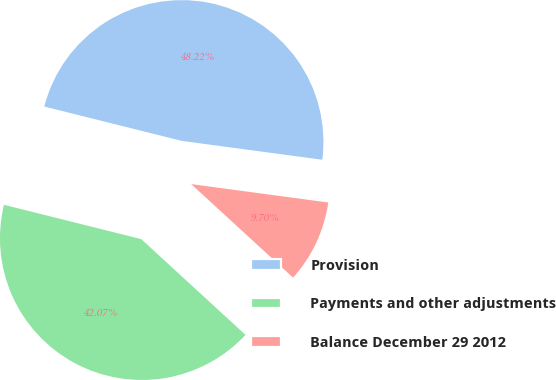<chart> <loc_0><loc_0><loc_500><loc_500><pie_chart><fcel>Provision<fcel>Payments and other adjustments<fcel>Balance December 29 2012<nl><fcel>48.22%<fcel>42.07%<fcel>9.7%<nl></chart> 